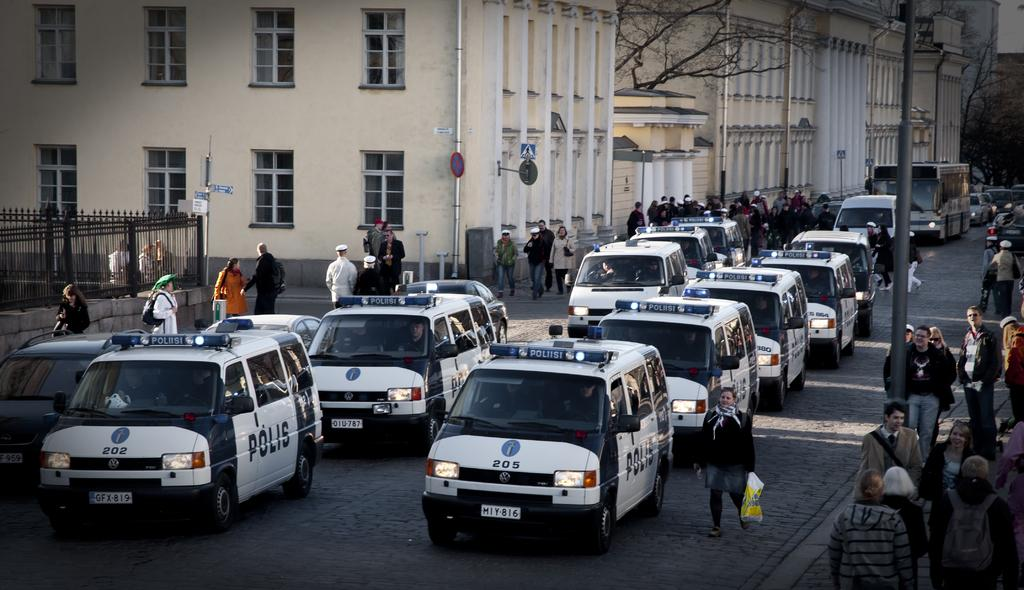<image>
Share a concise interpretation of the image provided. Polis cars that are lined on the street 